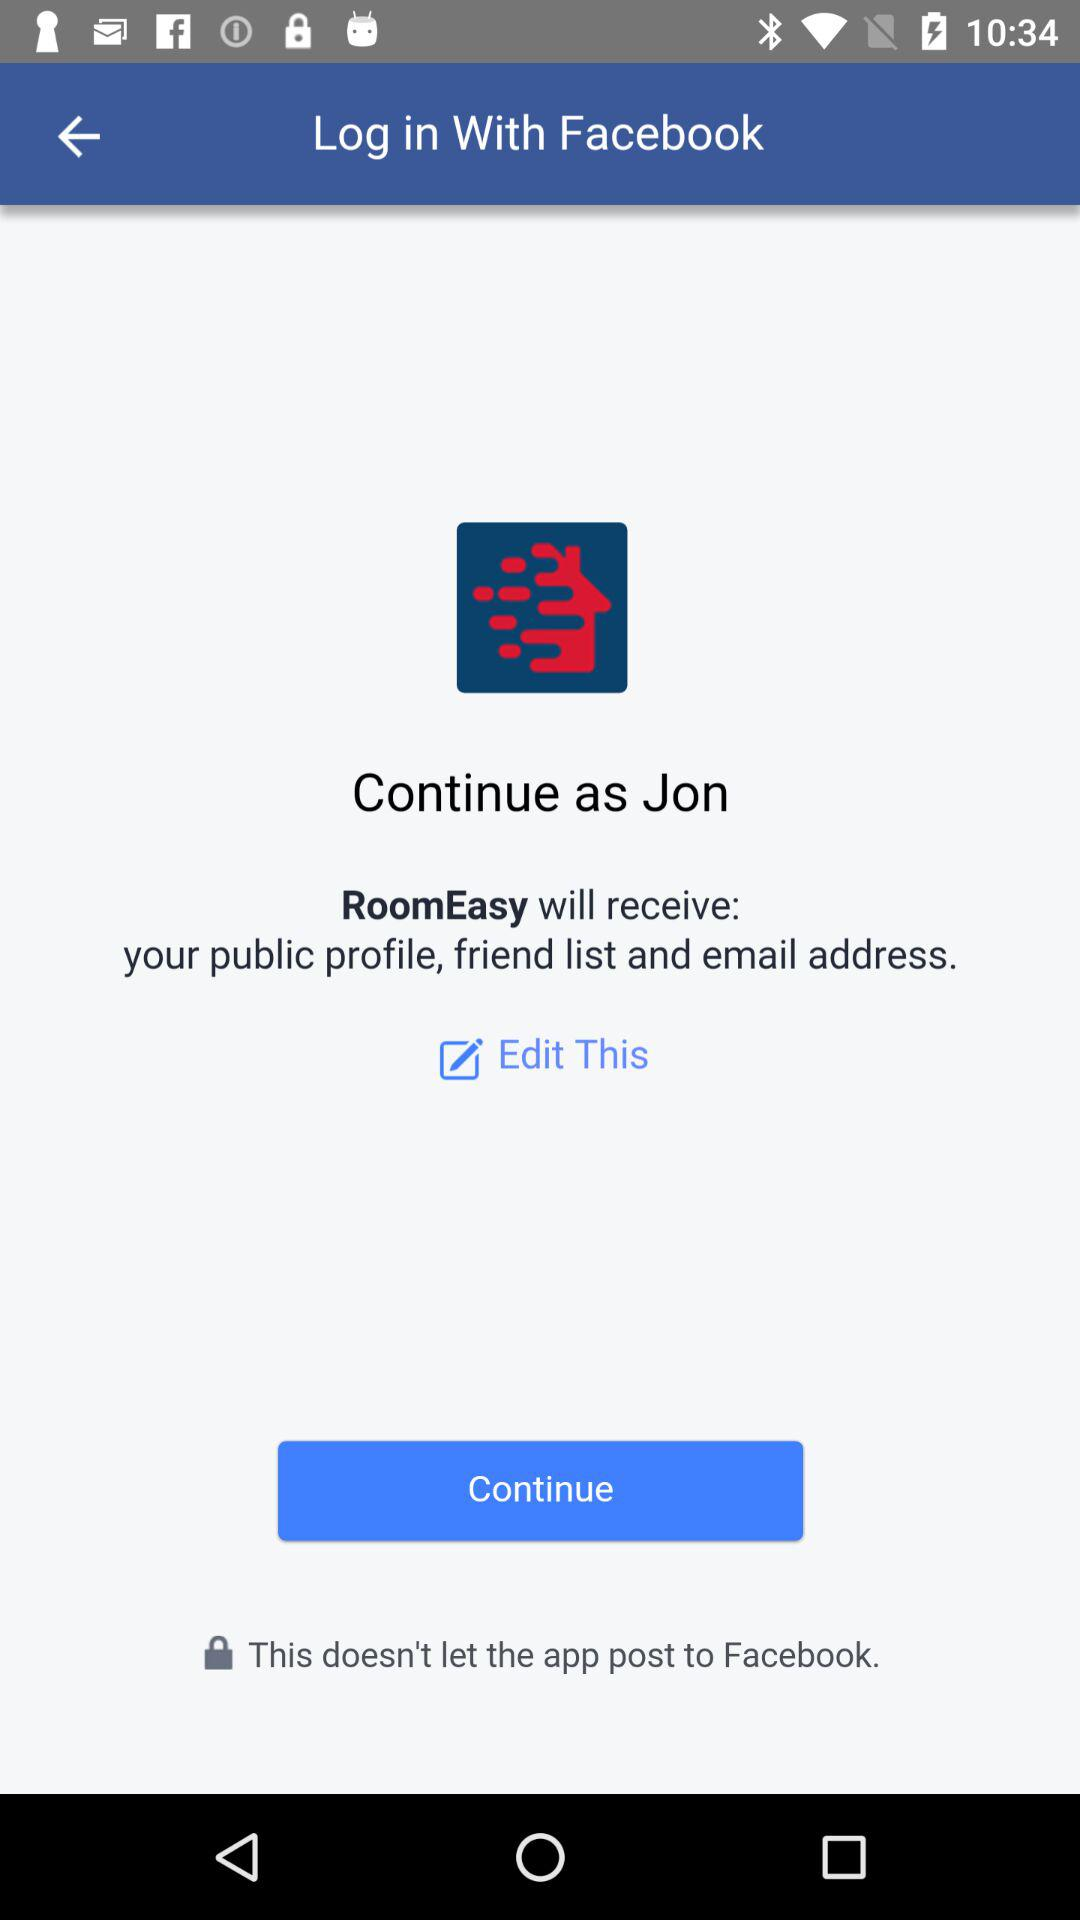What is the name of the user? The name of the user is Jon. 